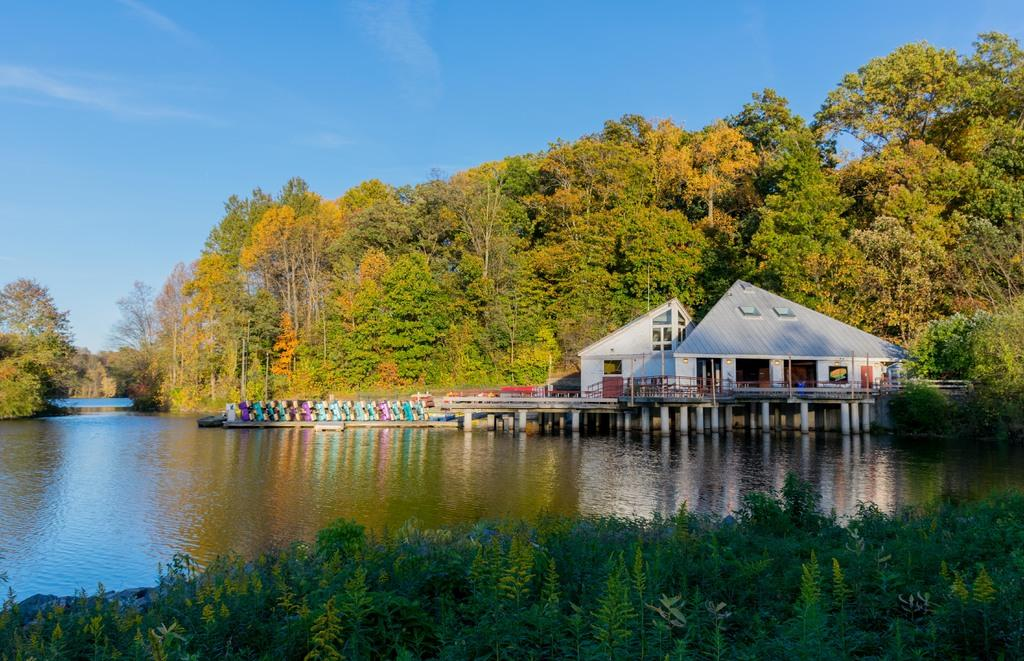Where was the image taken? The image was clicked outside. What can be seen in the middle of the image? There are trees, water, and a house in the middle of the image. What is visible at the top of the image? The sky is visible at the top of the image. What type of floor can be seen in the image? There is no floor visible in the image, as it was taken outside. Can you identify any prose in the image? There is no prose present in the image, as it is a photograph and not a written text. 